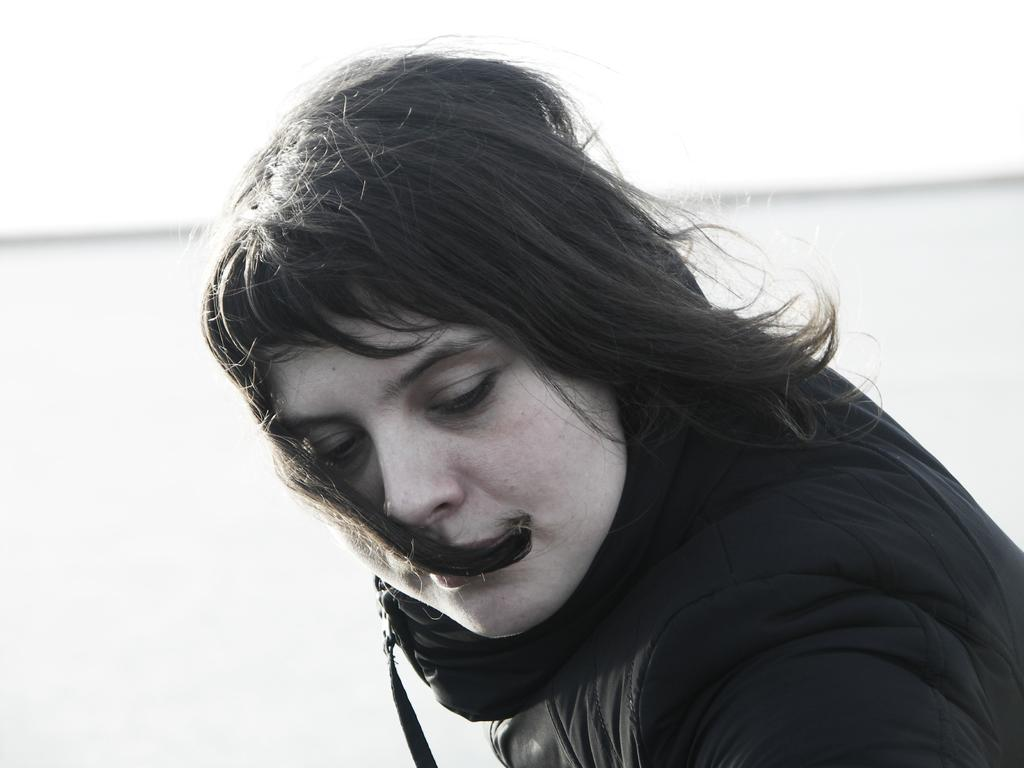Who is the main subject in the image? There is a woman in the image. Can you describe the background of the image? The background of the image is blurry. What type of fan can be seen in the image? There is no fan present in the image. Can you describe the field in the image? There is no field present in the image. 